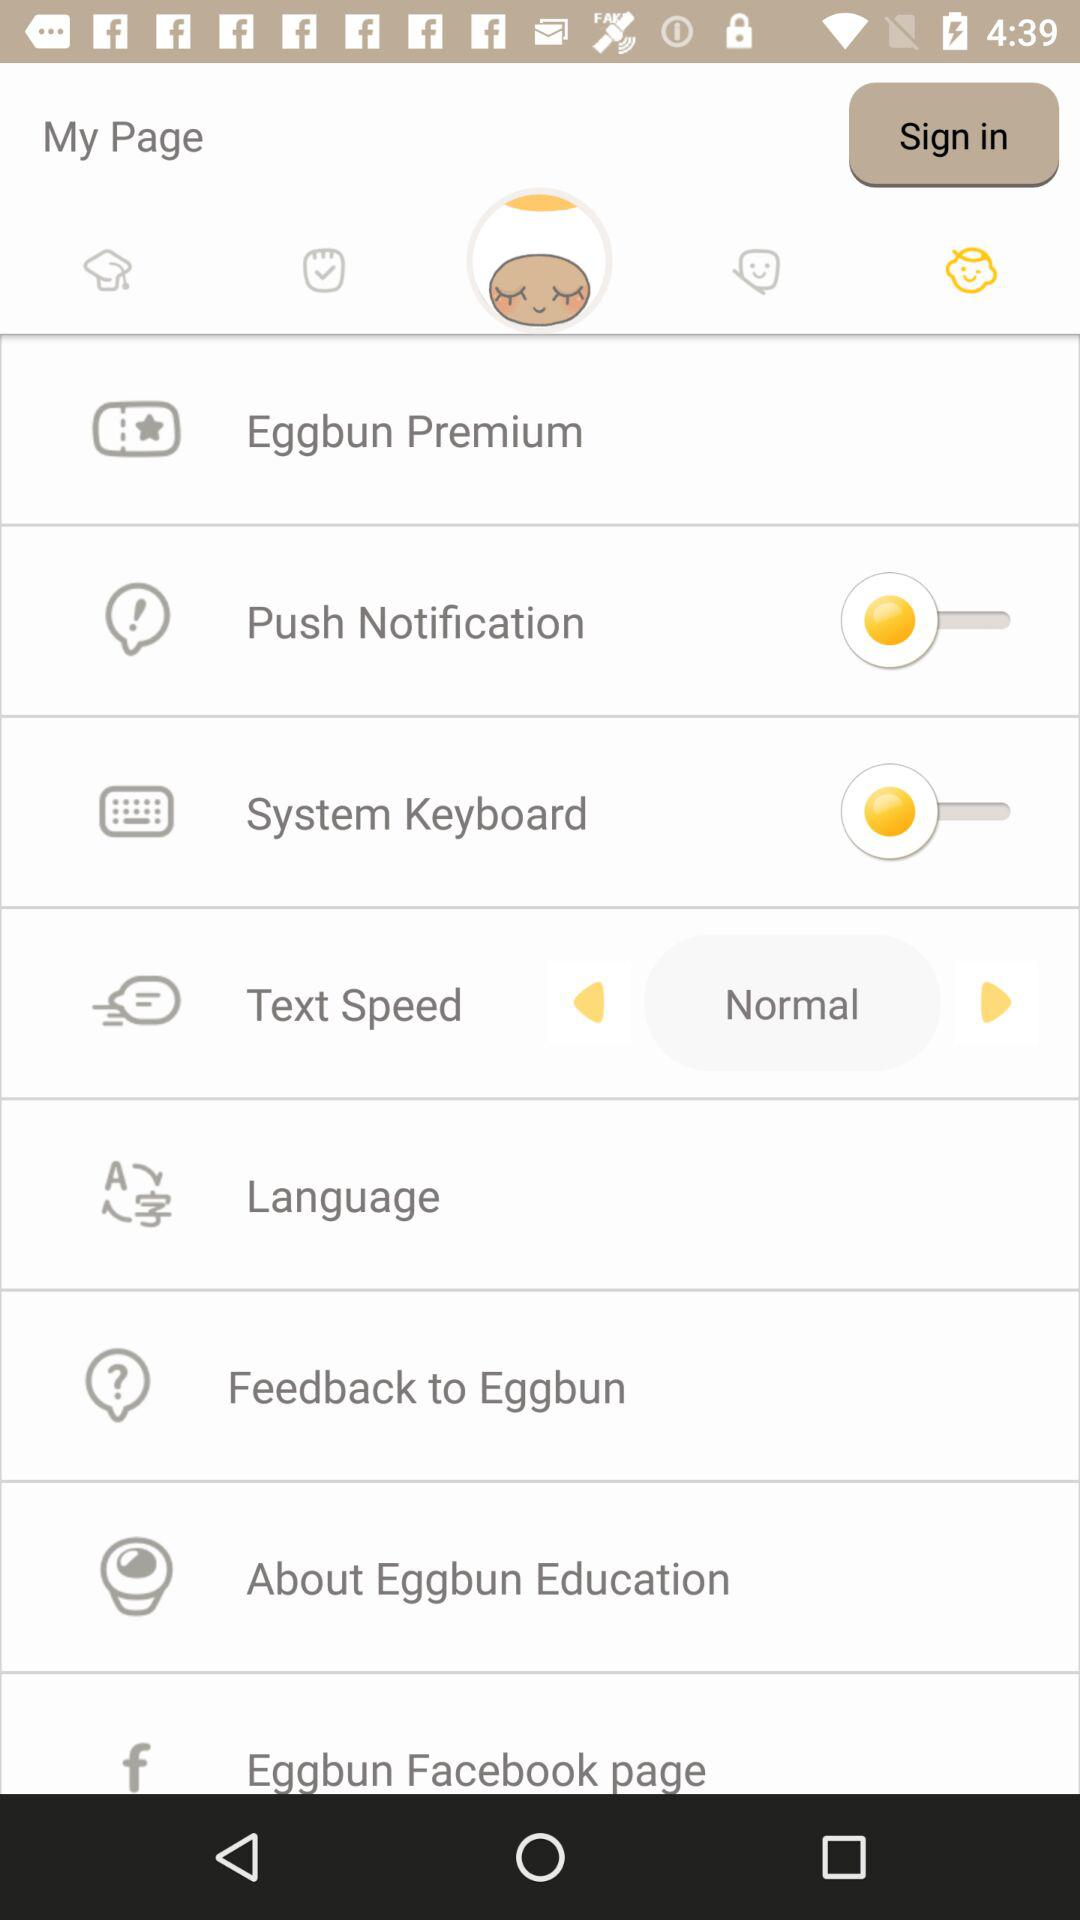What is the text speed? The text speed is normal. 